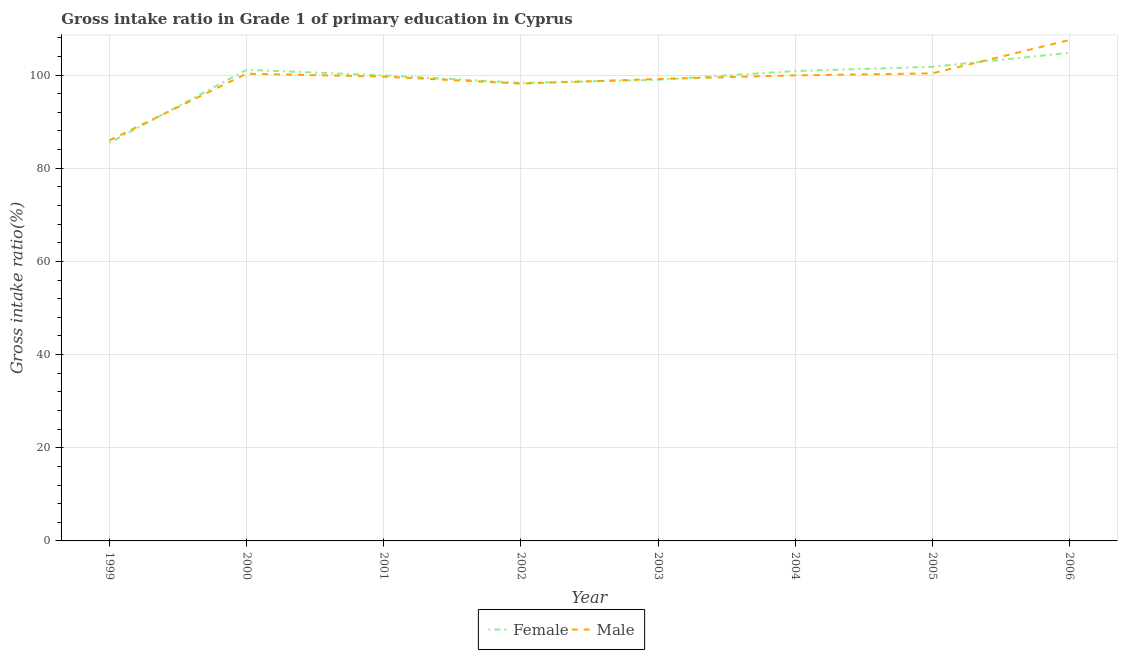How many different coloured lines are there?
Offer a terse response. 2. Does the line corresponding to gross intake ratio(male) intersect with the line corresponding to gross intake ratio(female)?
Offer a very short reply. Yes. Is the number of lines equal to the number of legend labels?
Your answer should be very brief. Yes. What is the gross intake ratio(female) in 2005?
Offer a very short reply. 101.77. Across all years, what is the maximum gross intake ratio(female)?
Give a very brief answer. 104.77. Across all years, what is the minimum gross intake ratio(male)?
Offer a terse response. 85.97. What is the total gross intake ratio(male) in the graph?
Your answer should be very brief. 791.06. What is the difference between the gross intake ratio(male) in 2000 and that in 2005?
Ensure brevity in your answer.  -0.07. What is the difference between the gross intake ratio(male) in 2005 and the gross intake ratio(female) in 2006?
Provide a short and direct response. -4.41. What is the average gross intake ratio(male) per year?
Your answer should be very brief. 98.88. In the year 2005, what is the difference between the gross intake ratio(female) and gross intake ratio(male)?
Ensure brevity in your answer.  1.41. In how many years, is the gross intake ratio(male) greater than 68 %?
Make the answer very short. 8. What is the ratio of the gross intake ratio(male) in 1999 to that in 2001?
Your response must be concise. 0.86. Is the difference between the gross intake ratio(male) in 2001 and 2002 greater than the difference between the gross intake ratio(female) in 2001 and 2002?
Provide a succinct answer. No. What is the difference between the highest and the second highest gross intake ratio(female)?
Provide a short and direct response. 3.01. What is the difference between the highest and the lowest gross intake ratio(female)?
Make the answer very short. 19.34. In how many years, is the gross intake ratio(male) greater than the average gross intake ratio(male) taken over all years?
Offer a terse response. 6. Does the gross intake ratio(female) monotonically increase over the years?
Your answer should be very brief. No. Is the gross intake ratio(male) strictly greater than the gross intake ratio(female) over the years?
Provide a short and direct response. No. Is the gross intake ratio(female) strictly less than the gross intake ratio(male) over the years?
Offer a terse response. No. How many lines are there?
Your response must be concise. 2. How many years are there in the graph?
Provide a short and direct response. 8. What is the difference between two consecutive major ticks on the Y-axis?
Provide a short and direct response. 20. How many legend labels are there?
Keep it short and to the point. 2. How are the legend labels stacked?
Keep it short and to the point. Horizontal. What is the title of the graph?
Keep it short and to the point. Gross intake ratio in Grade 1 of primary education in Cyprus. What is the label or title of the Y-axis?
Your answer should be very brief. Gross intake ratio(%). What is the Gross intake ratio(%) of Female in 1999?
Provide a short and direct response. 85.44. What is the Gross intake ratio(%) in Male in 1999?
Make the answer very short. 85.97. What is the Gross intake ratio(%) in Female in 2000?
Your response must be concise. 101.12. What is the Gross intake ratio(%) of Male in 2000?
Provide a short and direct response. 100.29. What is the Gross intake ratio(%) in Female in 2001?
Provide a short and direct response. 99.94. What is the Gross intake ratio(%) of Male in 2001?
Provide a succinct answer. 99.67. What is the Gross intake ratio(%) in Female in 2002?
Provide a short and direct response. 98.32. What is the Gross intake ratio(%) in Male in 2002?
Provide a succinct answer. 98.17. What is the Gross intake ratio(%) of Female in 2003?
Keep it short and to the point. 98.98. What is the Gross intake ratio(%) of Male in 2003?
Offer a terse response. 99.15. What is the Gross intake ratio(%) of Female in 2004?
Offer a very short reply. 100.87. What is the Gross intake ratio(%) of Male in 2004?
Give a very brief answer. 99.94. What is the Gross intake ratio(%) in Female in 2005?
Offer a terse response. 101.77. What is the Gross intake ratio(%) in Male in 2005?
Your answer should be compact. 100.36. What is the Gross intake ratio(%) in Female in 2006?
Keep it short and to the point. 104.77. What is the Gross intake ratio(%) in Male in 2006?
Your answer should be very brief. 107.52. Across all years, what is the maximum Gross intake ratio(%) of Female?
Provide a short and direct response. 104.77. Across all years, what is the maximum Gross intake ratio(%) of Male?
Your answer should be very brief. 107.52. Across all years, what is the minimum Gross intake ratio(%) in Female?
Provide a short and direct response. 85.44. Across all years, what is the minimum Gross intake ratio(%) of Male?
Give a very brief answer. 85.97. What is the total Gross intake ratio(%) of Female in the graph?
Make the answer very short. 791.21. What is the total Gross intake ratio(%) of Male in the graph?
Offer a very short reply. 791.06. What is the difference between the Gross intake ratio(%) of Female in 1999 and that in 2000?
Your answer should be very brief. -15.68. What is the difference between the Gross intake ratio(%) of Male in 1999 and that in 2000?
Offer a very short reply. -14.33. What is the difference between the Gross intake ratio(%) of Female in 1999 and that in 2001?
Provide a succinct answer. -14.5. What is the difference between the Gross intake ratio(%) in Male in 1999 and that in 2001?
Offer a terse response. -13.7. What is the difference between the Gross intake ratio(%) in Female in 1999 and that in 2002?
Your answer should be compact. -12.88. What is the difference between the Gross intake ratio(%) in Male in 1999 and that in 2002?
Your answer should be compact. -12.2. What is the difference between the Gross intake ratio(%) of Female in 1999 and that in 2003?
Your answer should be very brief. -13.54. What is the difference between the Gross intake ratio(%) of Male in 1999 and that in 2003?
Your response must be concise. -13.18. What is the difference between the Gross intake ratio(%) in Female in 1999 and that in 2004?
Provide a succinct answer. -15.43. What is the difference between the Gross intake ratio(%) of Male in 1999 and that in 2004?
Offer a very short reply. -13.97. What is the difference between the Gross intake ratio(%) in Female in 1999 and that in 2005?
Keep it short and to the point. -16.33. What is the difference between the Gross intake ratio(%) in Male in 1999 and that in 2005?
Offer a very short reply. -14.4. What is the difference between the Gross intake ratio(%) of Female in 1999 and that in 2006?
Your answer should be very brief. -19.34. What is the difference between the Gross intake ratio(%) of Male in 1999 and that in 2006?
Keep it short and to the point. -21.55. What is the difference between the Gross intake ratio(%) in Female in 2000 and that in 2001?
Your answer should be compact. 1.18. What is the difference between the Gross intake ratio(%) in Male in 2000 and that in 2001?
Ensure brevity in your answer.  0.62. What is the difference between the Gross intake ratio(%) in Female in 2000 and that in 2002?
Keep it short and to the point. 2.81. What is the difference between the Gross intake ratio(%) in Male in 2000 and that in 2002?
Keep it short and to the point. 2.12. What is the difference between the Gross intake ratio(%) in Female in 2000 and that in 2003?
Your answer should be very brief. 2.15. What is the difference between the Gross intake ratio(%) of Male in 2000 and that in 2003?
Your answer should be very brief. 1.14. What is the difference between the Gross intake ratio(%) of Female in 2000 and that in 2004?
Make the answer very short. 0.25. What is the difference between the Gross intake ratio(%) of Male in 2000 and that in 2004?
Provide a succinct answer. 0.35. What is the difference between the Gross intake ratio(%) in Female in 2000 and that in 2005?
Ensure brevity in your answer.  -0.65. What is the difference between the Gross intake ratio(%) in Male in 2000 and that in 2005?
Give a very brief answer. -0.07. What is the difference between the Gross intake ratio(%) in Female in 2000 and that in 2006?
Your response must be concise. -3.65. What is the difference between the Gross intake ratio(%) of Male in 2000 and that in 2006?
Offer a terse response. -7.23. What is the difference between the Gross intake ratio(%) in Female in 2001 and that in 2002?
Provide a short and direct response. 1.63. What is the difference between the Gross intake ratio(%) of Male in 2001 and that in 2002?
Offer a very short reply. 1.5. What is the difference between the Gross intake ratio(%) of Female in 2001 and that in 2003?
Your response must be concise. 0.96. What is the difference between the Gross intake ratio(%) in Male in 2001 and that in 2003?
Make the answer very short. 0.52. What is the difference between the Gross intake ratio(%) in Female in 2001 and that in 2004?
Give a very brief answer. -0.93. What is the difference between the Gross intake ratio(%) in Male in 2001 and that in 2004?
Give a very brief answer. -0.27. What is the difference between the Gross intake ratio(%) in Female in 2001 and that in 2005?
Your answer should be very brief. -1.83. What is the difference between the Gross intake ratio(%) of Male in 2001 and that in 2005?
Provide a succinct answer. -0.69. What is the difference between the Gross intake ratio(%) in Female in 2001 and that in 2006?
Provide a succinct answer. -4.83. What is the difference between the Gross intake ratio(%) of Male in 2001 and that in 2006?
Offer a terse response. -7.85. What is the difference between the Gross intake ratio(%) in Female in 2002 and that in 2003?
Make the answer very short. -0.66. What is the difference between the Gross intake ratio(%) of Male in 2002 and that in 2003?
Keep it short and to the point. -0.98. What is the difference between the Gross intake ratio(%) of Female in 2002 and that in 2004?
Your response must be concise. -2.55. What is the difference between the Gross intake ratio(%) in Male in 2002 and that in 2004?
Keep it short and to the point. -1.77. What is the difference between the Gross intake ratio(%) of Female in 2002 and that in 2005?
Offer a terse response. -3.45. What is the difference between the Gross intake ratio(%) of Male in 2002 and that in 2005?
Provide a succinct answer. -2.19. What is the difference between the Gross intake ratio(%) of Female in 2002 and that in 2006?
Give a very brief answer. -6.46. What is the difference between the Gross intake ratio(%) of Male in 2002 and that in 2006?
Your answer should be compact. -9.35. What is the difference between the Gross intake ratio(%) of Female in 2003 and that in 2004?
Make the answer very short. -1.89. What is the difference between the Gross intake ratio(%) of Male in 2003 and that in 2004?
Provide a succinct answer. -0.79. What is the difference between the Gross intake ratio(%) in Female in 2003 and that in 2005?
Keep it short and to the point. -2.79. What is the difference between the Gross intake ratio(%) in Male in 2003 and that in 2005?
Offer a very short reply. -1.22. What is the difference between the Gross intake ratio(%) in Female in 2003 and that in 2006?
Your response must be concise. -5.8. What is the difference between the Gross intake ratio(%) of Male in 2003 and that in 2006?
Your response must be concise. -8.37. What is the difference between the Gross intake ratio(%) of Female in 2004 and that in 2005?
Your answer should be compact. -0.9. What is the difference between the Gross intake ratio(%) of Male in 2004 and that in 2005?
Keep it short and to the point. -0.42. What is the difference between the Gross intake ratio(%) in Female in 2004 and that in 2006?
Make the answer very short. -3.91. What is the difference between the Gross intake ratio(%) in Male in 2004 and that in 2006?
Your answer should be compact. -7.58. What is the difference between the Gross intake ratio(%) of Female in 2005 and that in 2006?
Provide a succinct answer. -3.01. What is the difference between the Gross intake ratio(%) in Male in 2005 and that in 2006?
Make the answer very short. -7.16. What is the difference between the Gross intake ratio(%) in Female in 1999 and the Gross intake ratio(%) in Male in 2000?
Make the answer very short. -14.85. What is the difference between the Gross intake ratio(%) of Female in 1999 and the Gross intake ratio(%) of Male in 2001?
Keep it short and to the point. -14.23. What is the difference between the Gross intake ratio(%) of Female in 1999 and the Gross intake ratio(%) of Male in 2002?
Provide a short and direct response. -12.73. What is the difference between the Gross intake ratio(%) of Female in 1999 and the Gross intake ratio(%) of Male in 2003?
Your response must be concise. -13.71. What is the difference between the Gross intake ratio(%) in Female in 1999 and the Gross intake ratio(%) in Male in 2004?
Your answer should be very brief. -14.5. What is the difference between the Gross intake ratio(%) in Female in 1999 and the Gross intake ratio(%) in Male in 2005?
Offer a terse response. -14.92. What is the difference between the Gross intake ratio(%) of Female in 1999 and the Gross intake ratio(%) of Male in 2006?
Offer a very short reply. -22.08. What is the difference between the Gross intake ratio(%) in Female in 2000 and the Gross intake ratio(%) in Male in 2001?
Provide a succinct answer. 1.46. What is the difference between the Gross intake ratio(%) in Female in 2000 and the Gross intake ratio(%) in Male in 2002?
Provide a succinct answer. 2.95. What is the difference between the Gross intake ratio(%) in Female in 2000 and the Gross intake ratio(%) in Male in 2003?
Your response must be concise. 1.98. What is the difference between the Gross intake ratio(%) of Female in 2000 and the Gross intake ratio(%) of Male in 2004?
Offer a very short reply. 1.19. What is the difference between the Gross intake ratio(%) of Female in 2000 and the Gross intake ratio(%) of Male in 2005?
Provide a succinct answer. 0.76. What is the difference between the Gross intake ratio(%) of Female in 2000 and the Gross intake ratio(%) of Male in 2006?
Your response must be concise. -6.4. What is the difference between the Gross intake ratio(%) in Female in 2001 and the Gross intake ratio(%) in Male in 2002?
Provide a short and direct response. 1.77. What is the difference between the Gross intake ratio(%) in Female in 2001 and the Gross intake ratio(%) in Male in 2003?
Give a very brief answer. 0.8. What is the difference between the Gross intake ratio(%) of Female in 2001 and the Gross intake ratio(%) of Male in 2004?
Give a very brief answer. 0. What is the difference between the Gross intake ratio(%) in Female in 2001 and the Gross intake ratio(%) in Male in 2005?
Give a very brief answer. -0.42. What is the difference between the Gross intake ratio(%) in Female in 2001 and the Gross intake ratio(%) in Male in 2006?
Offer a terse response. -7.58. What is the difference between the Gross intake ratio(%) in Female in 2002 and the Gross intake ratio(%) in Male in 2003?
Offer a very short reply. -0.83. What is the difference between the Gross intake ratio(%) of Female in 2002 and the Gross intake ratio(%) of Male in 2004?
Give a very brief answer. -1.62. What is the difference between the Gross intake ratio(%) in Female in 2002 and the Gross intake ratio(%) in Male in 2005?
Your answer should be very brief. -2.05. What is the difference between the Gross intake ratio(%) of Female in 2002 and the Gross intake ratio(%) of Male in 2006?
Your answer should be very brief. -9.2. What is the difference between the Gross intake ratio(%) of Female in 2003 and the Gross intake ratio(%) of Male in 2004?
Your answer should be very brief. -0.96. What is the difference between the Gross intake ratio(%) in Female in 2003 and the Gross intake ratio(%) in Male in 2005?
Keep it short and to the point. -1.38. What is the difference between the Gross intake ratio(%) in Female in 2003 and the Gross intake ratio(%) in Male in 2006?
Offer a terse response. -8.54. What is the difference between the Gross intake ratio(%) of Female in 2004 and the Gross intake ratio(%) of Male in 2005?
Your answer should be compact. 0.51. What is the difference between the Gross intake ratio(%) in Female in 2004 and the Gross intake ratio(%) in Male in 2006?
Offer a very short reply. -6.65. What is the difference between the Gross intake ratio(%) of Female in 2005 and the Gross intake ratio(%) of Male in 2006?
Offer a terse response. -5.75. What is the average Gross intake ratio(%) in Female per year?
Provide a succinct answer. 98.9. What is the average Gross intake ratio(%) in Male per year?
Your response must be concise. 98.88. In the year 1999, what is the difference between the Gross intake ratio(%) in Female and Gross intake ratio(%) in Male?
Provide a succinct answer. -0.53. In the year 2000, what is the difference between the Gross intake ratio(%) of Female and Gross intake ratio(%) of Male?
Provide a succinct answer. 0.83. In the year 2001, what is the difference between the Gross intake ratio(%) in Female and Gross intake ratio(%) in Male?
Your answer should be compact. 0.27. In the year 2002, what is the difference between the Gross intake ratio(%) in Female and Gross intake ratio(%) in Male?
Keep it short and to the point. 0.15. In the year 2003, what is the difference between the Gross intake ratio(%) in Female and Gross intake ratio(%) in Male?
Your answer should be compact. -0.17. In the year 2004, what is the difference between the Gross intake ratio(%) of Female and Gross intake ratio(%) of Male?
Offer a very short reply. 0.93. In the year 2005, what is the difference between the Gross intake ratio(%) in Female and Gross intake ratio(%) in Male?
Provide a short and direct response. 1.41. In the year 2006, what is the difference between the Gross intake ratio(%) in Female and Gross intake ratio(%) in Male?
Your answer should be compact. -2.75. What is the ratio of the Gross intake ratio(%) in Female in 1999 to that in 2000?
Provide a short and direct response. 0.84. What is the ratio of the Gross intake ratio(%) in Male in 1999 to that in 2000?
Keep it short and to the point. 0.86. What is the ratio of the Gross intake ratio(%) in Female in 1999 to that in 2001?
Keep it short and to the point. 0.85. What is the ratio of the Gross intake ratio(%) of Male in 1999 to that in 2001?
Offer a terse response. 0.86. What is the ratio of the Gross intake ratio(%) in Female in 1999 to that in 2002?
Ensure brevity in your answer.  0.87. What is the ratio of the Gross intake ratio(%) in Male in 1999 to that in 2002?
Your response must be concise. 0.88. What is the ratio of the Gross intake ratio(%) of Female in 1999 to that in 2003?
Keep it short and to the point. 0.86. What is the ratio of the Gross intake ratio(%) in Male in 1999 to that in 2003?
Provide a short and direct response. 0.87. What is the ratio of the Gross intake ratio(%) of Female in 1999 to that in 2004?
Make the answer very short. 0.85. What is the ratio of the Gross intake ratio(%) in Male in 1999 to that in 2004?
Your answer should be very brief. 0.86. What is the ratio of the Gross intake ratio(%) in Female in 1999 to that in 2005?
Your answer should be very brief. 0.84. What is the ratio of the Gross intake ratio(%) in Male in 1999 to that in 2005?
Keep it short and to the point. 0.86. What is the ratio of the Gross intake ratio(%) of Female in 1999 to that in 2006?
Offer a terse response. 0.82. What is the ratio of the Gross intake ratio(%) of Male in 1999 to that in 2006?
Provide a succinct answer. 0.8. What is the ratio of the Gross intake ratio(%) of Female in 2000 to that in 2001?
Keep it short and to the point. 1.01. What is the ratio of the Gross intake ratio(%) of Male in 2000 to that in 2001?
Give a very brief answer. 1.01. What is the ratio of the Gross intake ratio(%) of Female in 2000 to that in 2002?
Your answer should be compact. 1.03. What is the ratio of the Gross intake ratio(%) in Male in 2000 to that in 2002?
Make the answer very short. 1.02. What is the ratio of the Gross intake ratio(%) of Female in 2000 to that in 2003?
Provide a short and direct response. 1.02. What is the ratio of the Gross intake ratio(%) of Male in 2000 to that in 2003?
Your response must be concise. 1.01. What is the ratio of the Gross intake ratio(%) in Female in 2000 to that in 2005?
Your answer should be compact. 0.99. What is the ratio of the Gross intake ratio(%) in Male in 2000 to that in 2005?
Your answer should be very brief. 1. What is the ratio of the Gross intake ratio(%) of Female in 2000 to that in 2006?
Your response must be concise. 0.97. What is the ratio of the Gross intake ratio(%) in Male in 2000 to that in 2006?
Ensure brevity in your answer.  0.93. What is the ratio of the Gross intake ratio(%) of Female in 2001 to that in 2002?
Provide a short and direct response. 1.02. What is the ratio of the Gross intake ratio(%) of Male in 2001 to that in 2002?
Your answer should be compact. 1.02. What is the ratio of the Gross intake ratio(%) in Female in 2001 to that in 2003?
Your answer should be very brief. 1.01. What is the ratio of the Gross intake ratio(%) in Female in 2001 to that in 2004?
Make the answer very short. 0.99. What is the ratio of the Gross intake ratio(%) of Male in 2001 to that in 2005?
Your answer should be very brief. 0.99. What is the ratio of the Gross intake ratio(%) in Female in 2001 to that in 2006?
Give a very brief answer. 0.95. What is the ratio of the Gross intake ratio(%) of Male in 2001 to that in 2006?
Your answer should be very brief. 0.93. What is the ratio of the Gross intake ratio(%) of Female in 2002 to that in 2003?
Your response must be concise. 0.99. What is the ratio of the Gross intake ratio(%) of Female in 2002 to that in 2004?
Your answer should be very brief. 0.97. What is the ratio of the Gross intake ratio(%) in Male in 2002 to that in 2004?
Make the answer very short. 0.98. What is the ratio of the Gross intake ratio(%) of Female in 2002 to that in 2005?
Your answer should be very brief. 0.97. What is the ratio of the Gross intake ratio(%) of Male in 2002 to that in 2005?
Ensure brevity in your answer.  0.98. What is the ratio of the Gross intake ratio(%) of Female in 2002 to that in 2006?
Give a very brief answer. 0.94. What is the ratio of the Gross intake ratio(%) in Female in 2003 to that in 2004?
Keep it short and to the point. 0.98. What is the ratio of the Gross intake ratio(%) in Male in 2003 to that in 2004?
Offer a very short reply. 0.99. What is the ratio of the Gross intake ratio(%) of Female in 2003 to that in 2005?
Provide a succinct answer. 0.97. What is the ratio of the Gross intake ratio(%) of Male in 2003 to that in 2005?
Offer a very short reply. 0.99. What is the ratio of the Gross intake ratio(%) of Female in 2003 to that in 2006?
Your answer should be compact. 0.94. What is the ratio of the Gross intake ratio(%) in Male in 2003 to that in 2006?
Offer a very short reply. 0.92. What is the ratio of the Gross intake ratio(%) of Female in 2004 to that in 2005?
Provide a succinct answer. 0.99. What is the ratio of the Gross intake ratio(%) of Male in 2004 to that in 2005?
Give a very brief answer. 1. What is the ratio of the Gross intake ratio(%) of Female in 2004 to that in 2006?
Your answer should be very brief. 0.96. What is the ratio of the Gross intake ratio(%) of Male in 2004 to that in 2006?
Make the answer very short. 0.93. What is the ratio of the Gross intake ratio(%) in Female in 2005 to that in 2006?
Make the answer very short. 0.97. What is the ratio of the Gross intake ratio(%) of Male in 2005 to that in 2006?
Offer a terse response. 0.93. What is the difference between the highest and the second highest Gross intake ratio(%) in Female?
Your answer should be compact. 3.01. What is the difference between the highest and the second highest Gross intake ratio(%) of Male?
Your answer should be compact. 7.16. What is the difference between the highest and the lowest Gross intake ratio(%) of Female?
Your response must be concise. 19.34. What is the difference between the highest and the lowest Gross intake ratio(%) of Male?
Provide a succinct answer. 21.55. 